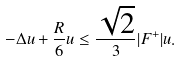<formula> <loc_0><loc_0><loc_500><loc_500>- \Delta u + \frac { R } { 6 } u \leq \frac { \sqrt { 2 } } { 3 } | F ^ { + } | u .</formula> 